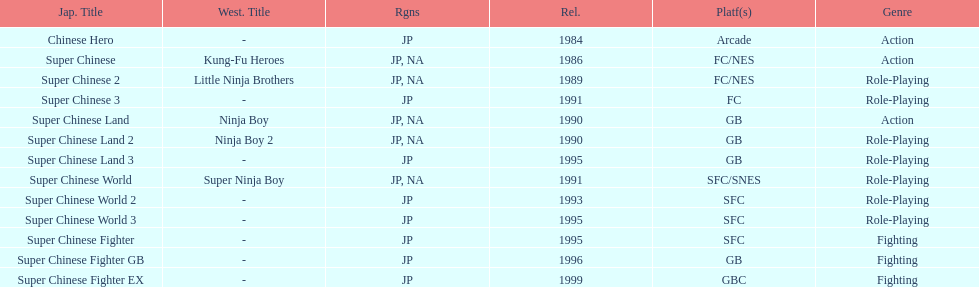The first year a game was released in north america 1986. 